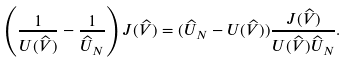<formula> <loc_0><loc_0><loc_500><loc_500>\left ( \frac { 1 } { U ( \widehat { V } ) } - \frac { 1 } { \widehat { U } _ { N } } \right ) J ( \widehat { V } ) = ( \widehat { U } _ { N } - U ( \widehat { V } ) ) \frac { J ( \widehat { V } ) } { U ( \widehat { V } ) \widehat { U } _ { N } } .</formula> 